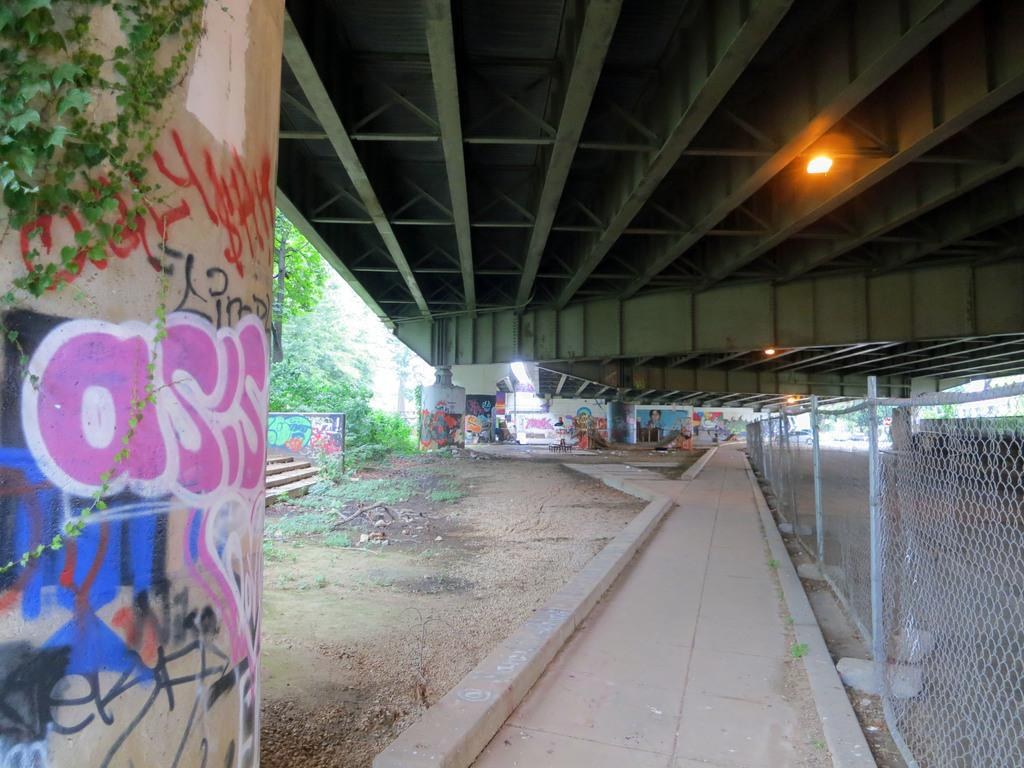What is depicted on the wall in the image? There is graffiti on a wall in the image. What type of natural elements can be seen in the image? There are trees visible in the image. Where is the light located in the image? The light is on the right side of the image. What is present on the right side of the image besides the light? There is a mesh on the right side of the image. Can you see a ghost interacting with the graffiti in the image? There is no ghost present in the image, and the graffiti is not being interacted with by any visible entities. 